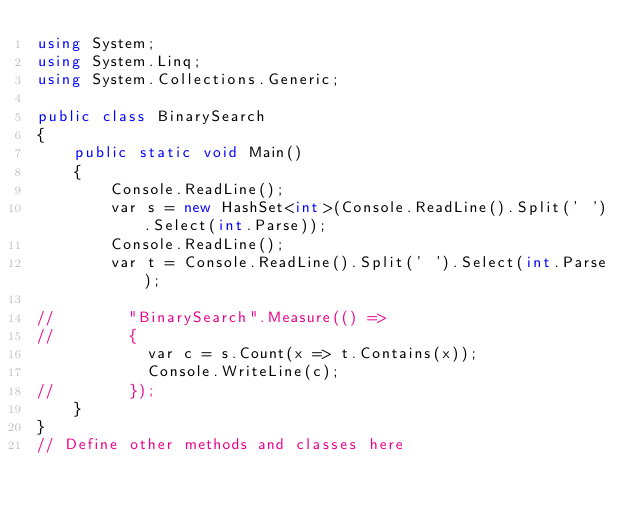<code> <loc_0><loc_0><loc_500><loc_500><_C#_>using System;
using System.Linq;
using System.Collections.Generic;

public class BinarySearch
{
    public static void Main()
    {
        Console.ReadLine();
        var s = new HashSet<int>(Console.ReadLine().Split(' ').Select(int.Parse));
        Console.ReadLine();
        var t = Console.ReadLine().Split(' ').Select(int.Parse);
    
//        "BinarySearch".Measure(() =>
//        {
            var c = s.Count(x => t.Contains(x));
            Console.WriteLine(c);
//        });
    }
}
// Define other methods and classes here</code> 